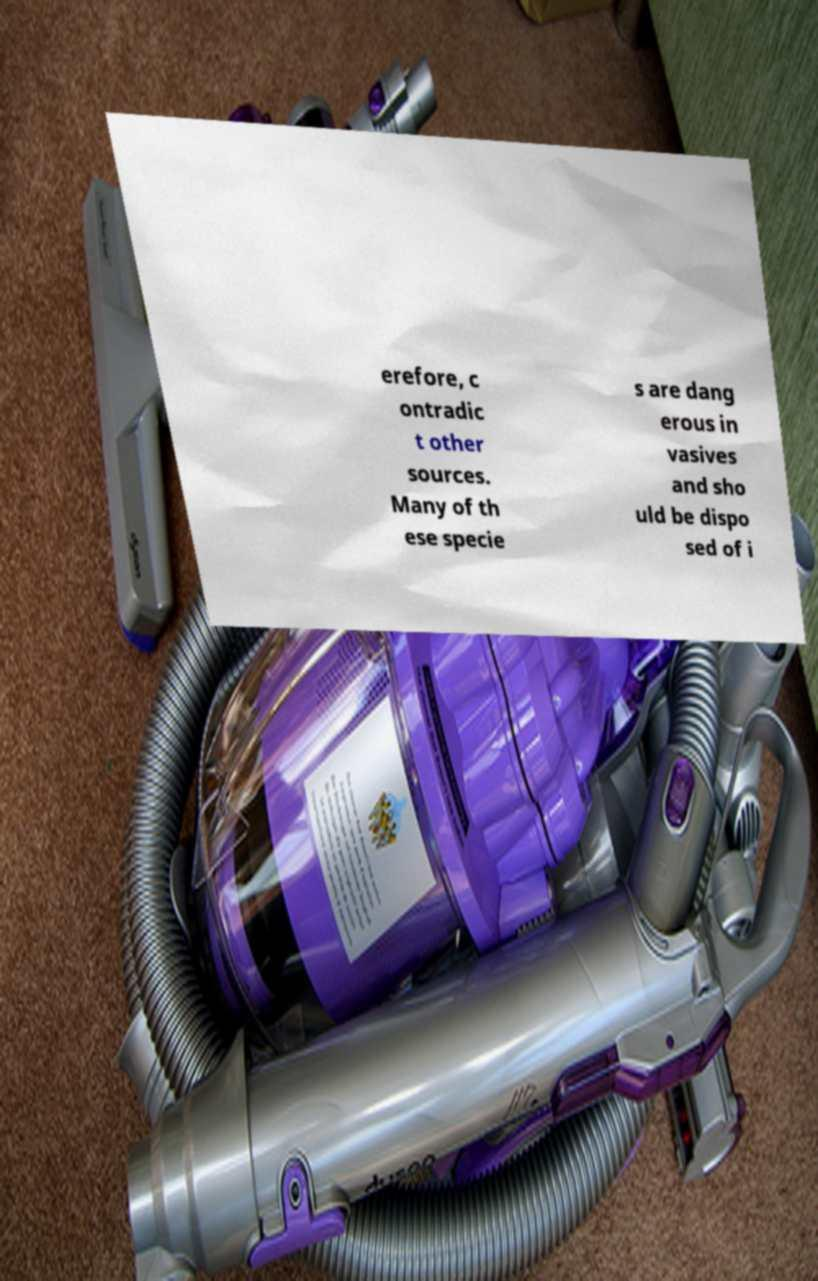Please identify and transcribe the text found in this image. erefore, c ontradic t other sources. Many of th ese specie s are dang erous in vasives and sho uld be dispo sed of i 